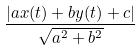<formula> <loc_0><loc_0><loc_500><loc_500>\frac { | a x ( t ) + b y ( t ) + c | } { \sqrt { a ^ { 2 } + b ^ { 2 } } }</formula> 